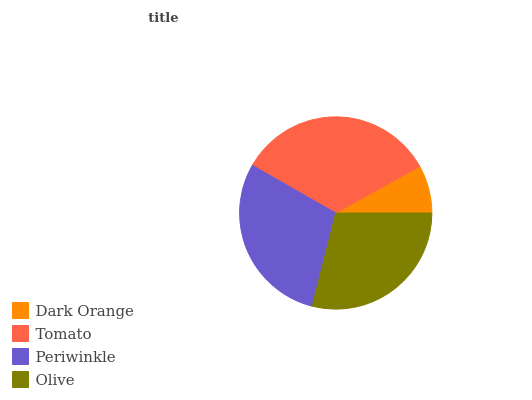Is Dark Orange the minimum?
Answer yes or no. Yes. Is Tomato the maximum?
Answer yes or no. Yes. Is Periwinkle the minimum?
Answer yes or no. No. Is Periwinkle the maximum?
Answer yes or no. No. Is Tomato greater than Periwinkle?
Answer yes or no. Yes. Is Periwinkle less than Tomato?
Answer yes or no. Yes. Is Periwinkle greater than Tomato?
Answer yes or no. No. Is Tomato less than Periwinkle?
Answer yes or no. No. Is Periwinkle the high median?
Answer yes or no. Yes. Is Olive the low median?
Answer yes or no. Yes. Is Dark Orange the high median?
Answer yes or no. No. Is Tomato the low median?
Answer yes or no. No. 